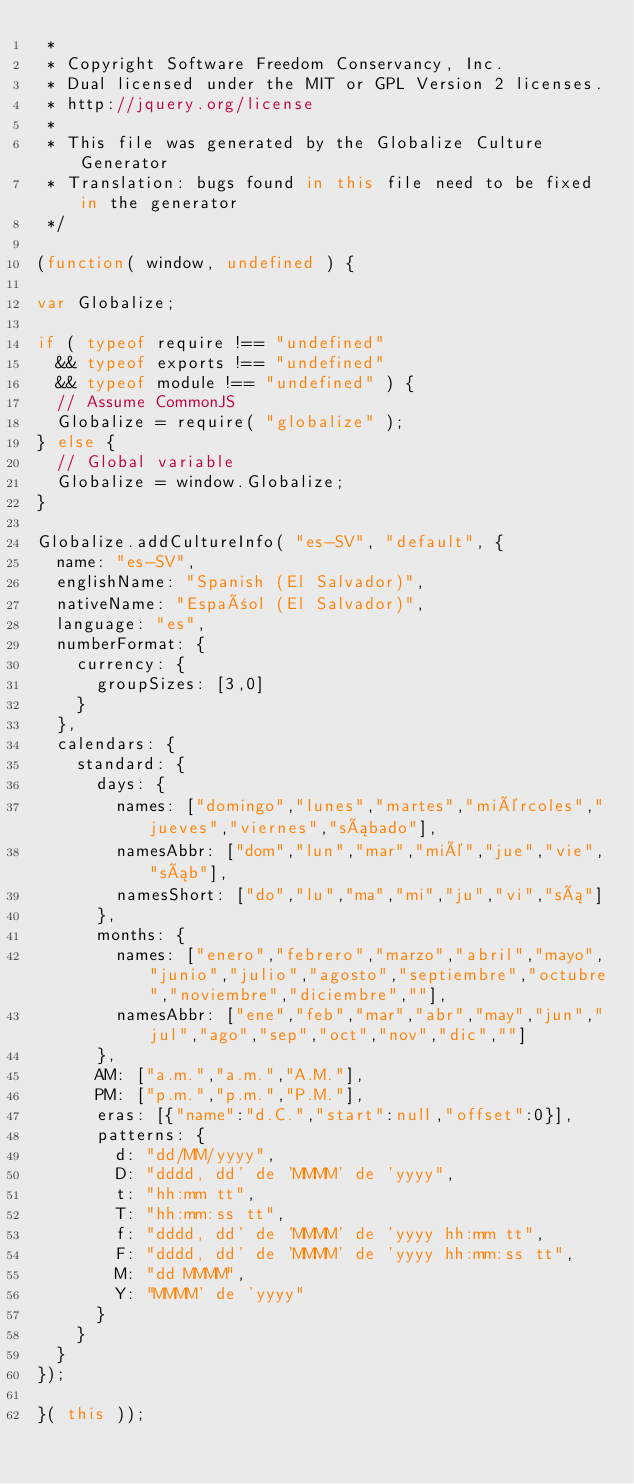Convert code to text. <code><loc_0><loc_0><loc_500><loc_500><_JavaScript_> *
 * Copyright Software Freedom Conservancy, Inc.
 * Dual licensed under the MIT or GPL Version 2 licenses.
 * http://jquery.org/license
 *
 * This file was generated by the Globalize Culture Generator
 * Translation: bugs found in this file need to be fixed in the generator
 */

(function( window, undefined ) {

var Globalize;

if ( typeof require !== "undefined"
	&& typeof exports !== "undefined"
	&& typeof module !== "undefined" ) {
	// Assume CommonJS
	Globalize = require( "globalize" );
} else {
	// Global variable
	Globalize = window.Globalize;
}

Globalize.addCultureInfo( "es-SV", "default", {
	name: "es-SV",
	englishName: "Spanish (El Salvador)",
	nativeName: "Español (El Salvador)",
	language: "es",
	numberFormat: {
		currency: {
			groupSizes: [3,0]
		}
	},
	calendars: {
		standard: {
			days: {
				names: ["domingo","lunes","martes","miércoles","jueves","viernes","sábado"],
				namesAbbr: ["dom","lun","mar","mié","jue","vie","sáb"],
				namesShort: ["do","lu","ma","mi","ju","vi","sá"]
			},
			months: {
				names: ["enero","febrero","marzo","abril","mayo","junio","julio","agosto","septiembre","octubre","noviembre","diciembre",""],
				namesAbbr: ["ene","feb","mar","abr","may","jun","jul","ago","sep","oct","nov","dic",""]
			},
			AM: ["a.m.","a.m.","A.M."],
			PM: ["p.m.","p.m.","P.M."],
			eras: [{"name":"d.C.","start":null,"offset":0}],
			patterns: {
				d: "dd/MM/yyyy",
				D: "dddd, dd' de 'MMMM' de 'yyyy",
				t: "hh:mm tt",
				T: "hh:mm:ss tt",
				f: "dddd, dd' de 'MMMM' de 'yyyy hh:mm tt",
				F: "dddd, dd' de 'MMMM' de 'yyyy hh:mm:ss tt",
				M: "dd MMMM",
				Y: "MMMM' de 'yyyy"
			}
		}
	}
});

}( this ));
</code> 